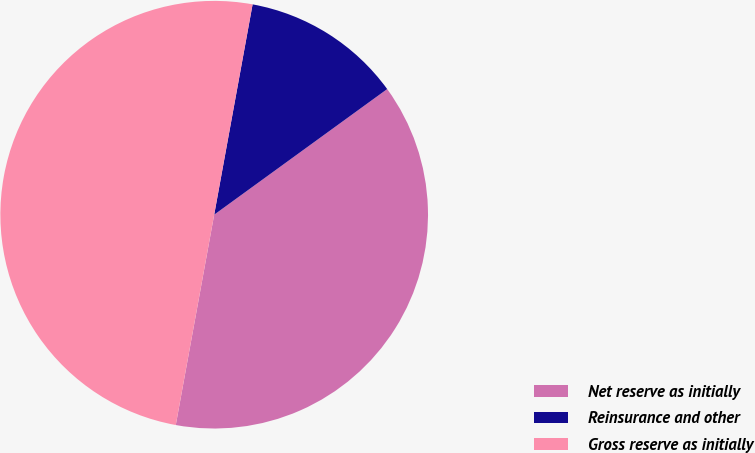Convert chart to OTSL. <chart><loc_0><loc_0><loc_500><loc_500><pie_chart><fcel>Net reserve as initially<fcel>Reinsurance and other<fcel>Gross reserve as initially<nl><fcel>37.87%<fcel>12.13%<fcel>50.0%<nl></chart> 